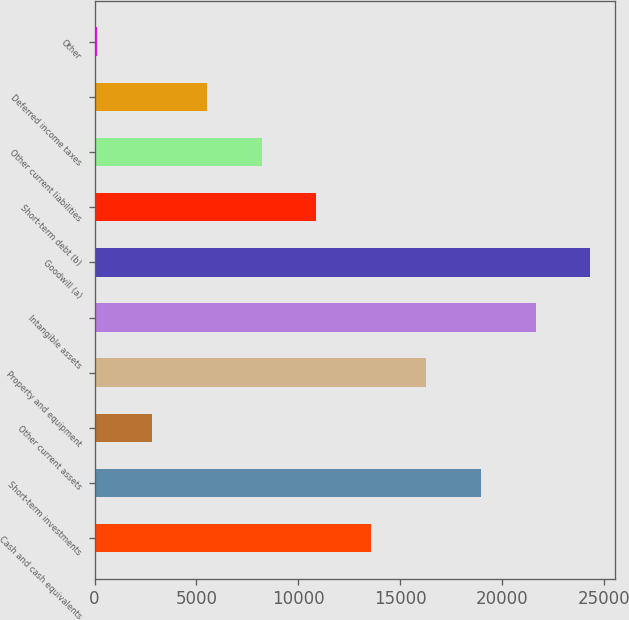Convert chart to OTSL. <chart><loc_0><loc_0><loc_500><loc_500><bar_chart><fcel>Cash and cash equivalents<fcel>Short-term investments<fcel>Other current assets<fcel>Property and equipment<fcel>Intangible assets<fcel>Goodwill (a)<fcel>Short-term debt (b)<fcel>Other current liabilities<fcel>Deferred income taxes<fcel>Other<nl><fcel>13570<fcel>18945.6<fcel>2818.8<fcel>16257.8<fcel>21633.4<fcel>24321.2<fcel>10882.2<fcel>8194.4<fcel>5506.6<fcel>131<nl></chart> 